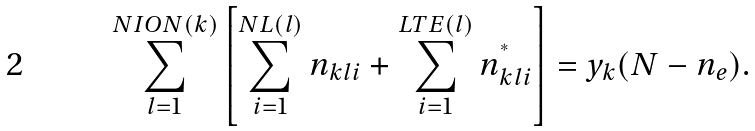Convert formula to latex. <formula><loc_0><loc_0><loc_500><loc_500>\sum _ { l = 1 } ^ { N I O N ( k ) } \left [ \sum _ { i = 1 } ^ { N L ( l ) } n _ { k l i } + \sum _ { i = 1 } ^ { L T E ( l ) } n _ { k l i } ^ { ^ { * } } \right ] = y _ { k } ( N - n _ { e } ) .</formula> 